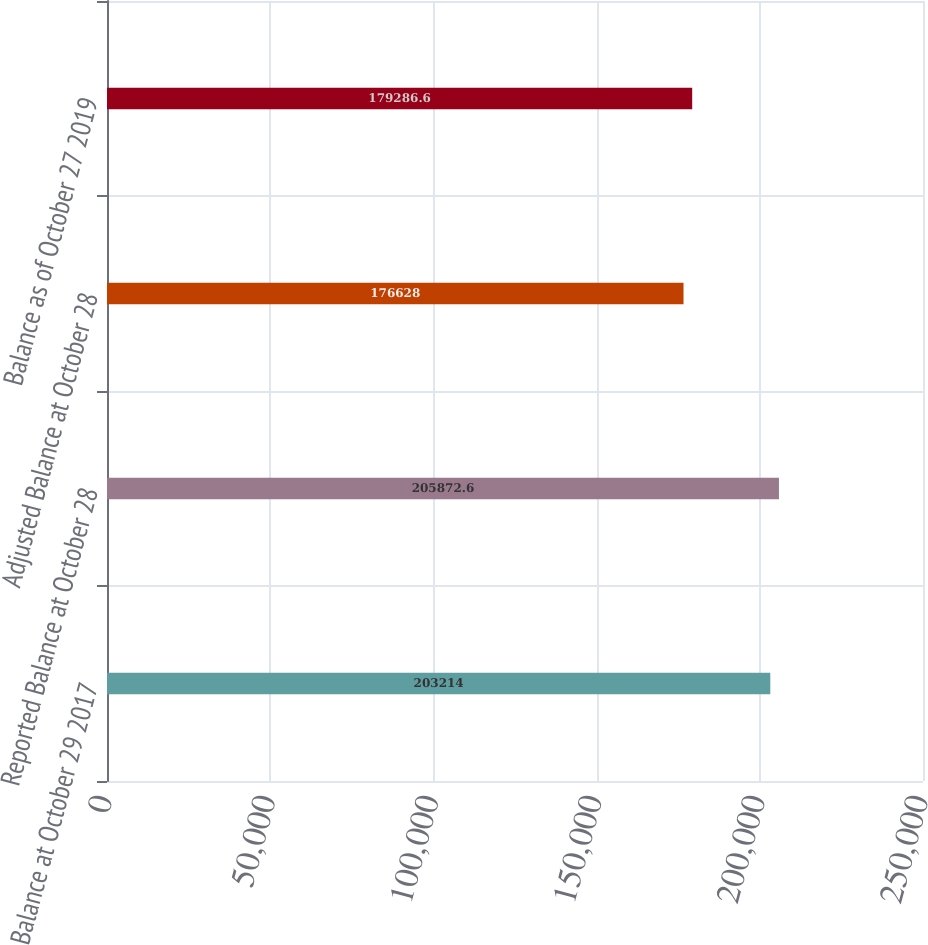<chart> <loc_0><loc_0><loc_500><loc_500><bar_chart><fcel>Balance at October 29 2017<fcel>Reported Balance at October 28<fcel>Adjusted Balance at October 28<fcel>Balance as of October 27 2019<nl><fcel>203214<fcel>205873<fcel>176628<fcel>179287<nl></chart> 